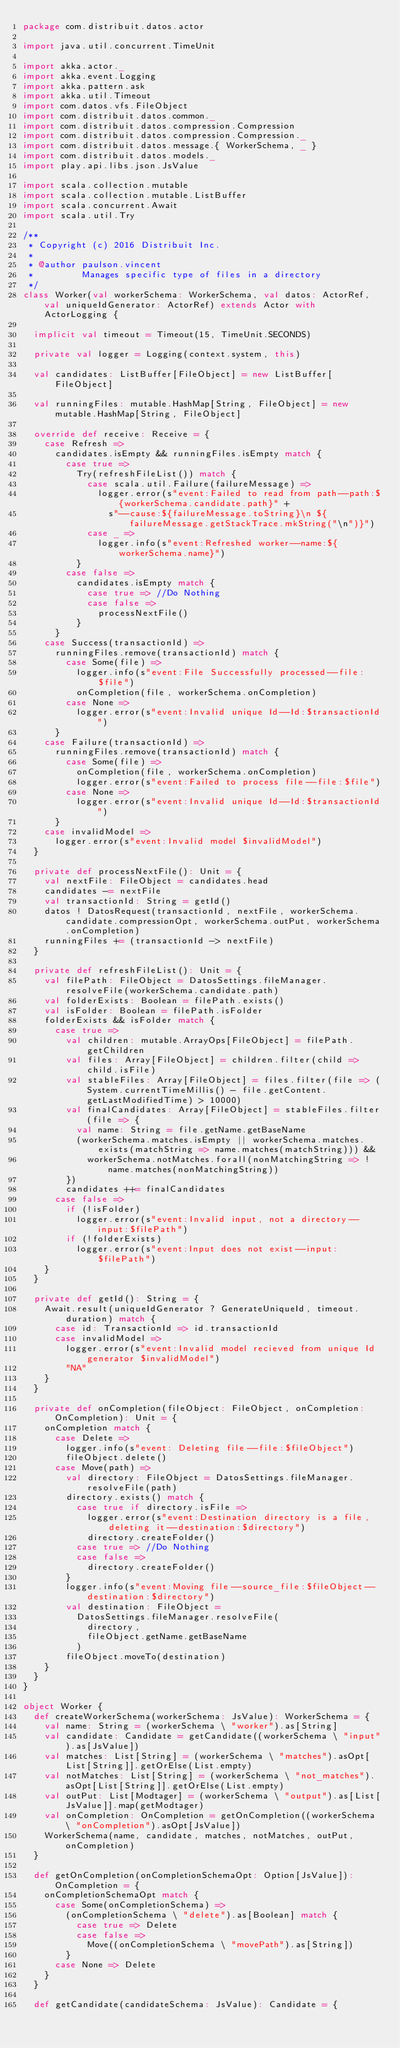Convert code to text. <code><loc_0><loc_0><loc_500><loc_500><_Scala_>package com.distribuit.datos.actor

import java.util.concurrent.TimeUnit

import akka.actor._
import akka.event.Logging
import akka.pattern.ask
import akka.util.Timeout
import com.datos.vfs.FileObject
import com.distribuit.datos.common._
import com.distribuit.datos.compression.Compression
import com.distribuit.datos.compression.Compression._
import com.distribuit.datos.message.{ WorkerSchema, _ }
import com.distribuit.datos.models._
import play.api.libs.json.JsValue

import scala.collection.mutable
import scala.collection.mutable.ListBuffer
import scala.concurrent.Await
import scala.util.Try

/**
 * Copyright (c) 2016 Distribuit Inc.
 *
 * @author paulson.vincent
 *         Manages specific type of files in a directory
 */
class Worker(val workerSchema: WorkerSchema, val datos: ActorRef, val uniqueIdGenerator: ActorRef) extends Actor with ActorLogging {

  implicit val timeout = Timeout(15, TimeUnit.SECONDS)

  private val logger = Logging(context.system, this)

  val candidates: ListBuffer[FileObject] = new ListBuffer[FileObject]

  val runningFiles: mutable.HashMap[String, FileObject] = new mutable.HashMap[String, FileObject]

  override def receive: Receive = {
    case Refresh =>
      candidates.isEmpty && runningFiles.isEmpty match {
        case true =>
          Try(refreshFileList()) match {
            case scala.util.Failure(failureMessage) =>
              logger.error(s"event:Failed to read from path--path:${workerSchema.candidate.path}" +
                s"--cause:${failureMessage.toString}\n ${failureMessage.getStackTrace.mkString("\n")}")
            case _ =>
              logger.info(s"event:Refreshed worker--name:${workerSchema.name}")
          }
        case false =>
          candidates.isEmpty match {
            case true => //Do Nothing
            case false =>
              processNextFile()
          }
      }
    case Success(transactionId) =>
      runningFiles.remove(transactionId) match {
        case Some(file) =>
          logger.info(s"event:File Successfully processed--file:$file")
          onCompletion(file, workerSchema.onCompletion)
        case None =>
          logger.error(s"event:Invalid unique Id--Id:$transactionId")
      }
    case Failure(transactionId) =>
      runningFiles.remove(transactionId) match {
        case Some(file) =>
          onCompletion(file, workerSchema.onCompletion)
          logger.error(s"event:Failed to process file--file:$file")
        case None =>
          logger.error(s"event:Invalid unique Id--Id:$transactionId")
      }
    case invalidModel =>
      logger.error(s"event:Invalid model $invalidModel")
  }

  private def processNextFile(): Unit = {
    val nextFile: FileObject = candidates.head
    candidates -= nextFile
    val transactionId: String = getId()
    datos ! DatosRequest(transactionId, nextFile, workerSchema.candidate.compressionOpt, workerSchema.outPut, workerSchema.onCompletion)
    runningFiles += (transactionId -> nextFile)
  }

  private def refreshFileList(): Unit = {
    val filePath: FileObject = DatosSettings.fileManager.resolveFile(workerSchema.candidate.path)
    val folderExists: Boolean = filePath.exists()
    val isFolder: Boolean = filePath.isFolder
    folderExists && isFolder match {
      case true =>
        val children: mutable.ArrayOps[FileObject] = filePath.getChildren
        val files: Array[FileObject] = children.filter(child => child.isFile)
        val stableFiles: Array[FileObject] = files.filter(file => (System.currentTimeMillis() - file.getContent.getLastModifiedTime) > 10000)
        val finalCandidates: Array[FileObject] = stableFiles.filter(file => {
          val name: String = file.getName.getBaseName
          (workerSchema.matches.isEmpty || workerSchema.matches.exists(matchString => name.matches(matchString))) &&
            workerSchema.notMatches.forall(nonMatchingString => !name.matches(nonMatchingString))
        })
        candidates ++= finalCandidates
      case false =>
        if (!isFolder)
          logger.error(s"event:Invalid input, not a directory--input:$filePath")
        if (!folderExists)
          logger.error(s"event:Input does not exist--input:$filePath")
    }
  }

  private def getId(): String = {
    Await.result(uniqueIdGenerator ? GenerateUniqueId, timeout.duration) match {
      case id: TransactionId => id.transactionId
      case invalidModel =>
        logger.error(s"event:Invalid model recieved from unique Id generator $invalidModel")
        "NA"
    }
  }

  private def onCompletion(fileObject: FileObject, onCompletion: OnCompletion): Unit = {
    onCompletion match {
      case Delete =>
        logger.info(s"event: Deleting file--file:$fileObject")
        fileObject.delete()
      case Move(path) =>
        val directory: FileObject = DatosSettings.fileManager.resolveFile(path)
        directory.exists() match {
          case true if directory.isFile =>
            logger.error(s"event:Destination directory is a file, deleting it--destination:$directory")
            directory.createFolder()
          case true => //Do Nothing
          case false =>
            directory.createFolder()
        }
        logger.info(s"event:Moving file--source_file:$fileObject--destination:$directory")
        val destination: FileObject =
          DatosSettings.fileManager.resolveFile(
            directory,
            fileObject.getName.getBaseName
          )
        fileObject.moveTo(destination)
    }
  }
}

object Worker {
  def createWorkerSchema(workerSchema: JsValue): WorkerSchema = {
    val name: String = (workerSchema \ "worker").as[String]
    val candidate: Candidate = getCandidate((workerSchema \ "input").as[JsValue])
    val matches: List[String] = (workerSchema \ "matches").asOpt[List[String]].getOrElse(List.empty)
    val notMatches: List[String] = (workerSchema \ "not_matches").asOpt[List[String]].getOrElse(List.empty)
    val outPut: List[Modtager] = (workerSchema \ "output").as[List[JsValue]].map(getModtager)
    val onCompletion: OnCompletion = getOnCompletion((workerSchema \ "onCompletion").asOpt[JsValue])
    WorkerSchema(name, candidate, matches, notMatches, outPut, onCompletion)
  }

  def getOnCompletion(onCompletionSchemaOpt: Option[JsValue]): OnCompletion = {
    onCompletionSchemaOpt match {
      case Some(onCompletionSchema) =>
        (onCompletionSchema \ "delete").as[Boolean] match {
          case true => Delete
          case false =>
            Move((onCompletionSchema \ "movePath").as[String])
        }
      case None => Delete
    }
  }

  def getCandidate(candidateSchema: JsValue): Candidate = {</code> 